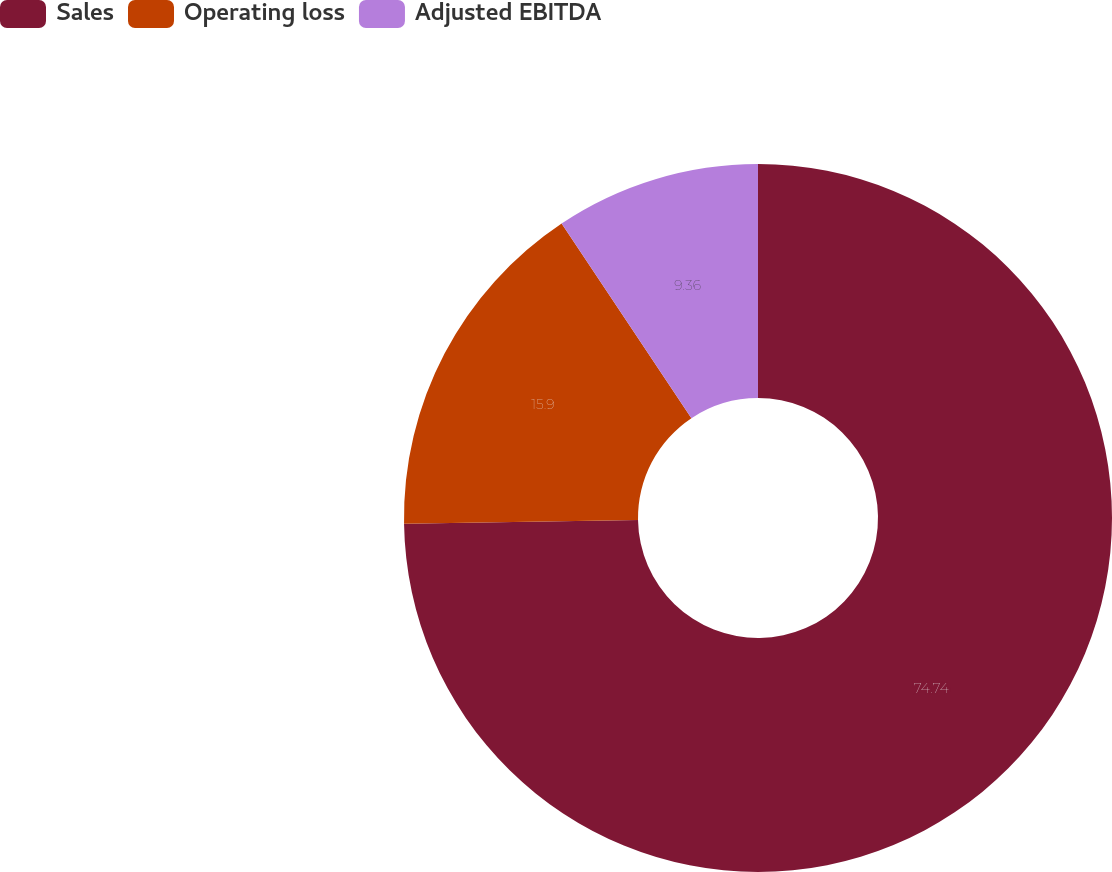Convert chart. <chart><loc_0><loc_0><loc_500><loc_500><pie_chart><fcel>Sales<fcel>Operating loss<fcel>Adjusted EBITDA<nl><fcel>74.75%<fcel>15.9%<fcel>9.36%<nl></chart> 